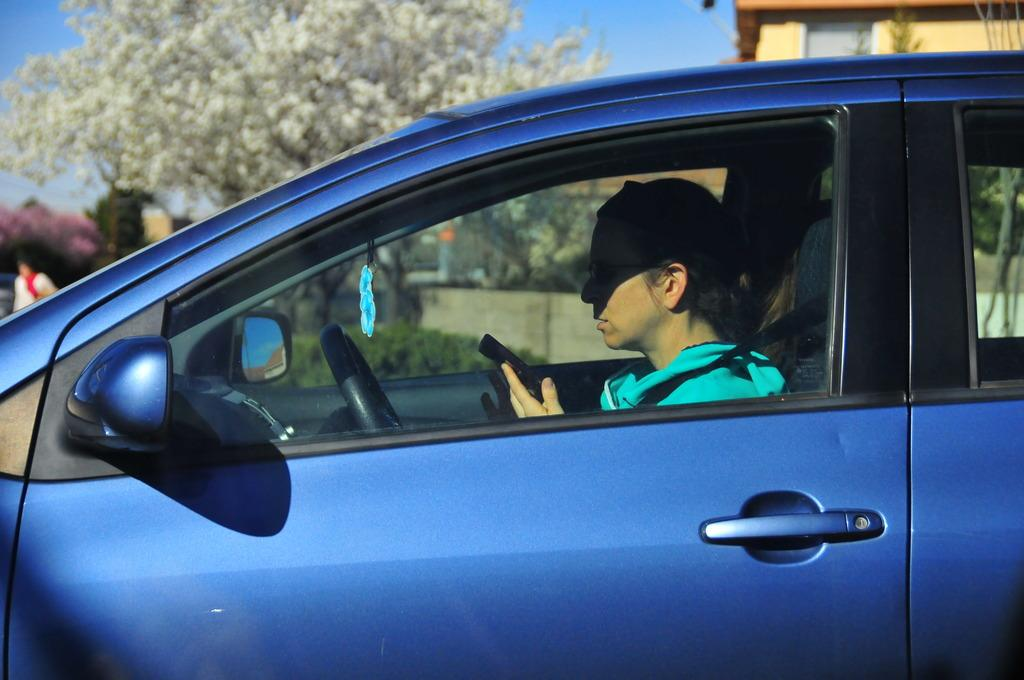What type of vehicle is in the image? There is a blue color car in the image. Who is inside the car? A: A man is sitting inside the car. What is the man holding in the image? The man is holding a mobile. What can be seen in the background of the image? There is a tree, a building, and the sky visible in the background of the image. Can you see a ghost sitting next to the man in the car? No, there is no ghost present in the image. Is there a dog visible in the car with the man? No, there is no dog present in the image. 